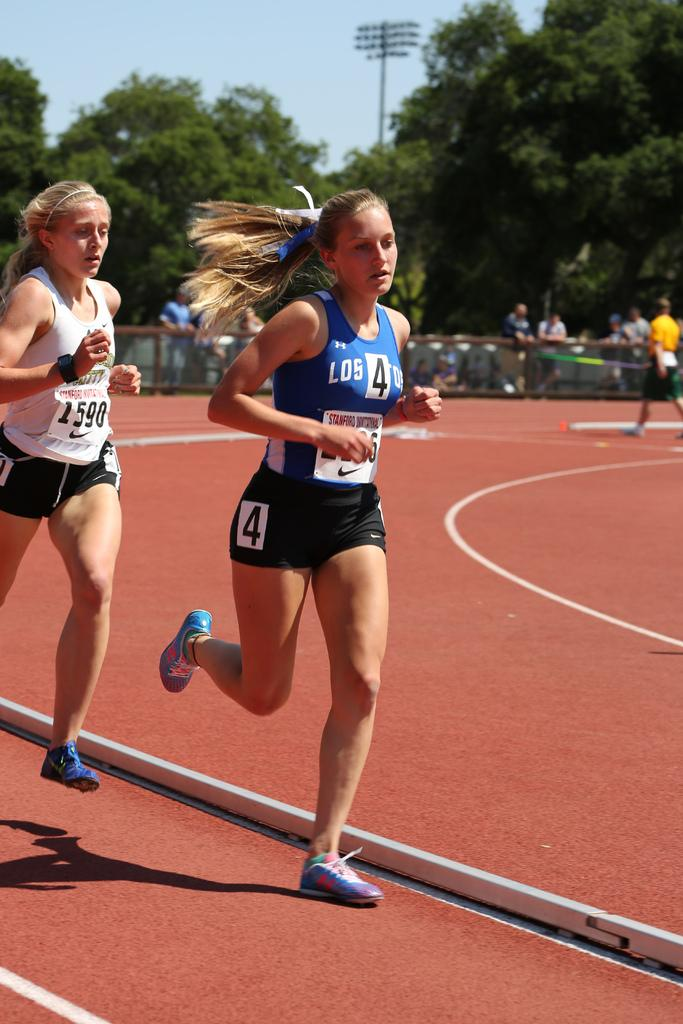<image>
Offer a succinct explanation of the picture presented. A woman in a blue track uniform sporting the number 4 is ahead a woman in a white track uniform sporting number 1590. 